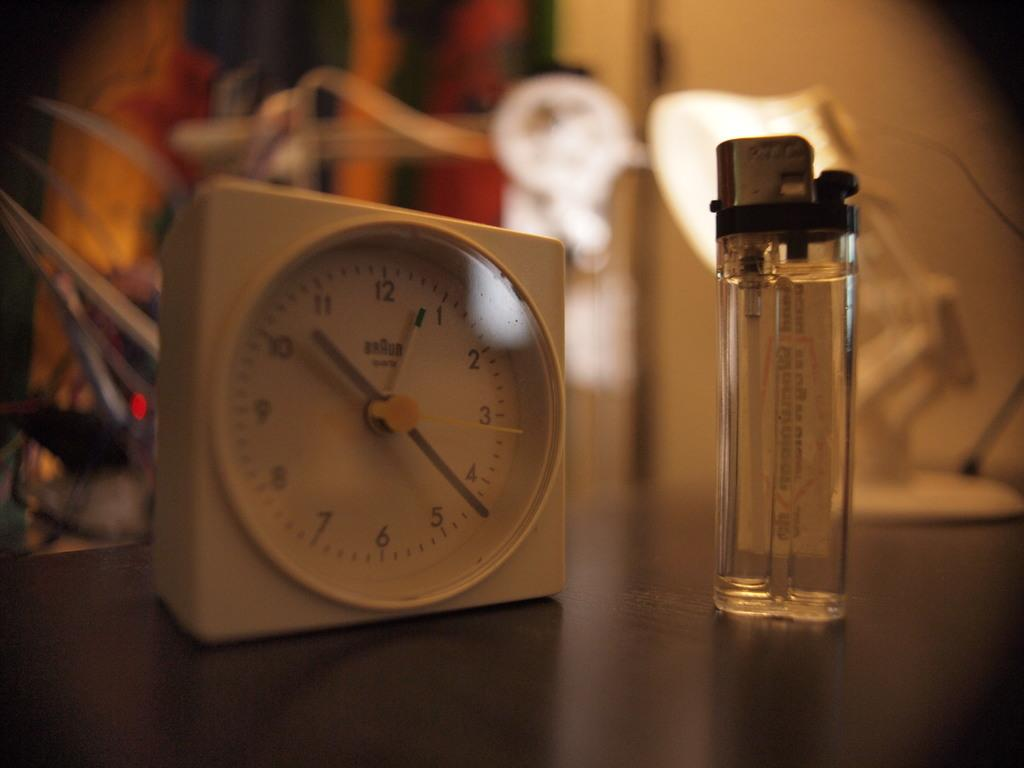<image>
Offer a succinct explanation of the picture presented. Braun clock sits on a table next to a clear lighter. 